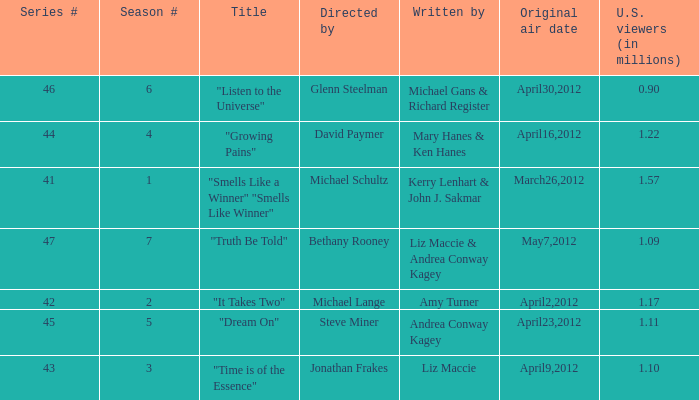How many millions of viewers did the episode written by Andrea Conway Kagey? 1.11. 